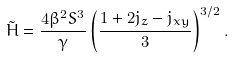Convert formula to latex. <formula><loc_0><loc_0><loc_500><loc_500>\tilde { H } = \frac { 4 \beta ^ { 2 } S ^ { 3 } } { \gamma } \left ( \frac { 1 + 2 j _ { z } - j _ { x y } } { 3 } \right ) ^ { 3 / 2 } .</formula> 